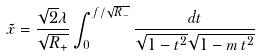Convert formula to latex. <formula><loc_0><loc_0><loc_500><loc_500>\tilde { x } = \frac { \sqrt { 2 } \lambda } { \sqrt { R _ { + } } } \int _ { 0 } ^ { f / \sqrt { R _ { - } } } \frac { d t } { \sqrt { 1 - t ^ { 2 } } \sqrt { 1 - m \, t ^ { 2 } } }</formula> 